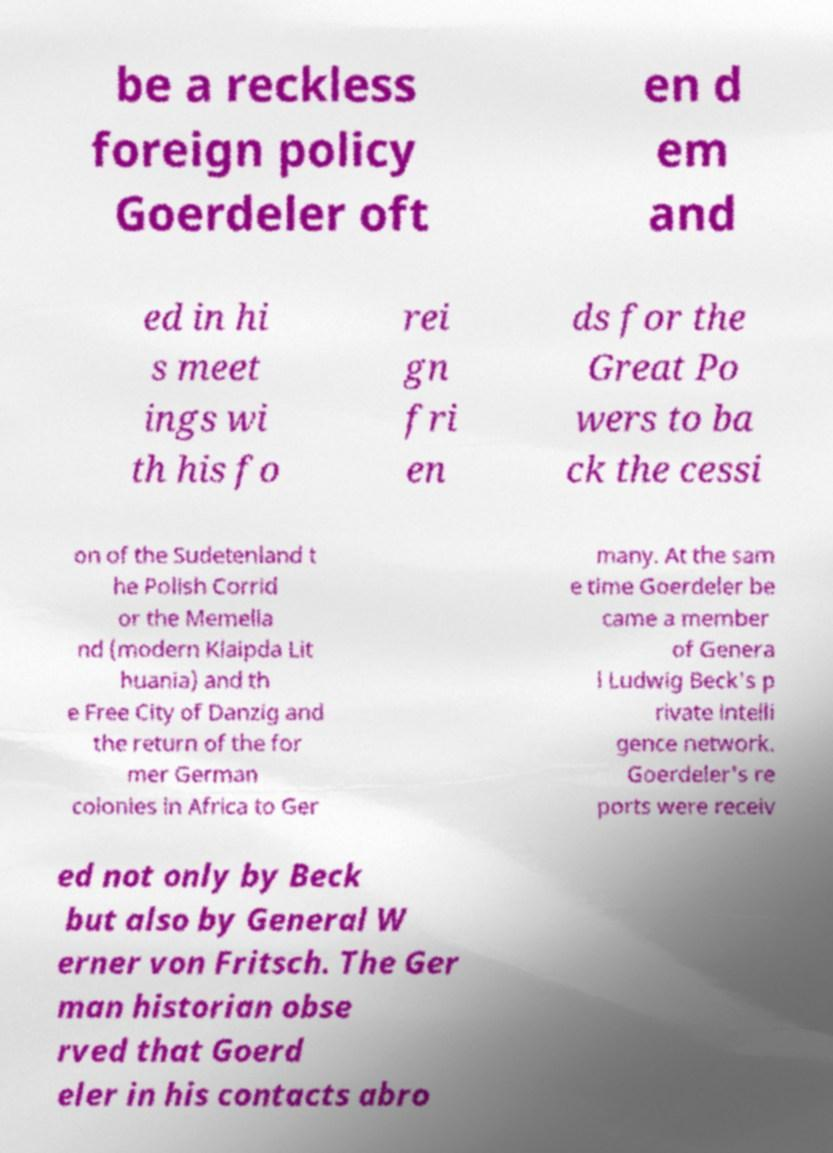Please identify and transcribe the text found in this image. be a reckless foreign policy Goerdeler oft en d em and ed in hi s meet ings wi th his fo rei gn fri en ds for the Great Po wers to ba ck the cessi on of the Sudetenland t he Polish Corrid or the Memella nd (modern Klaipda Lit huania) and th e Free City of Danzig and the return of the for mer German colonies in Africa to Ger many. At the sam e time Goerdeler be came a member of Genera l Ludwig Beck's p rivate intelli gence network. Goerdeler's re ports were receiv ed not only by Beck but also by General W erner von Fritsch. The Ger man historian obse rved that Goerd eler in his contacts abro 